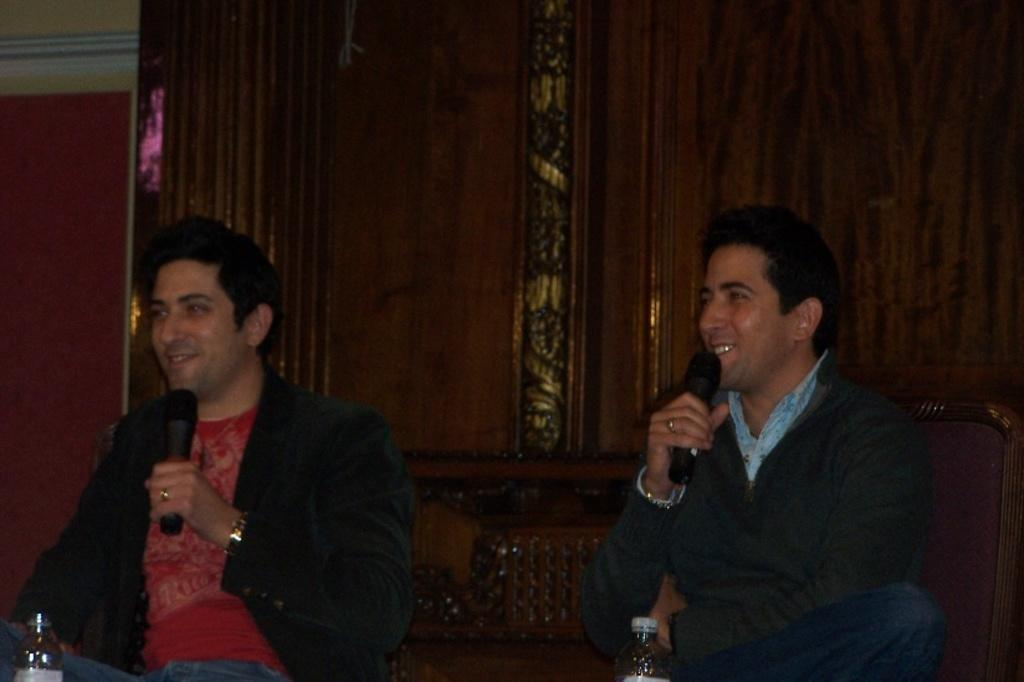What are the men in the image doing? The men in the image are sitting on chairs. Can you describe the man holding an object in his hand? There is a man holding a microphone in his hand. What can be seen on the table in the image? Water bottles are present on a table in the image. What type of dinner is being served on the table in the image? There is no dinner present in the image; only water bottles are visible on the table. Can you describe the color of the orange on the table in the image? There is no orange present in the image; only water bottles are visible on the table. 